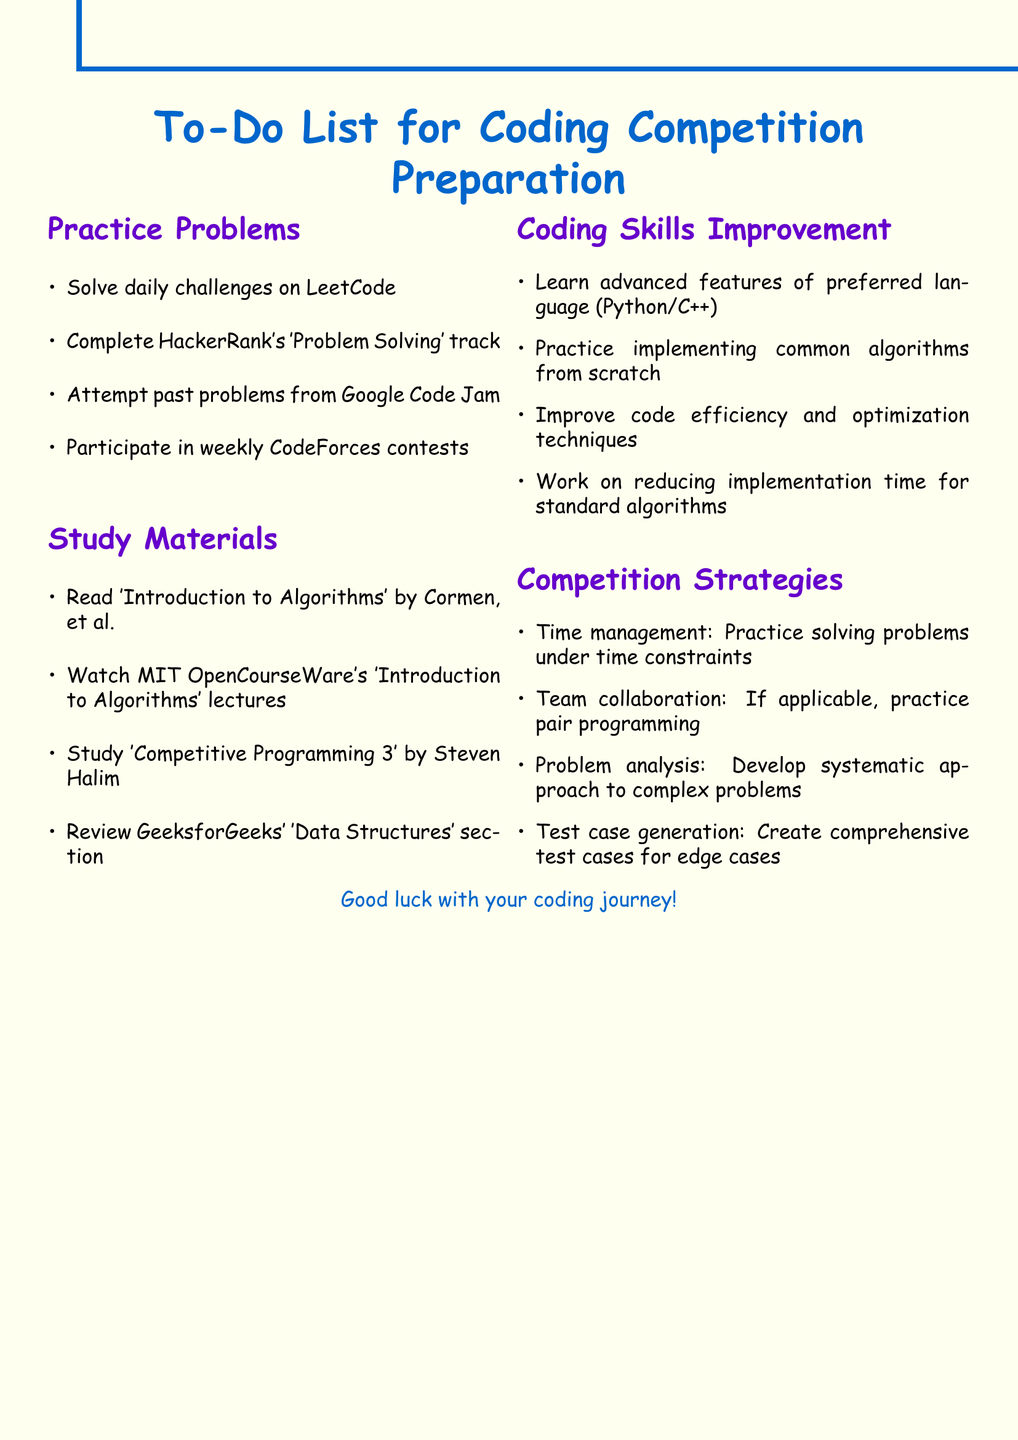What is one platform mentioned for daily challenges? The document lists LeetCode as a platform for daily challenges in the Practice Problems section.
Answer: LeetCode Which book is recommended for algorithms study? 'Introduction to Algorithms' by Cormen, Leiserson, Rivest, and Stein is mentioned as a recommended study material in the Study Materials section.
Answer: Introduction to Algorithms How many sections are there in total? The document contains four sections: Practice Problems, Study Materials, Coding Skills Improvement, and Competition Strategies.
Answer: Four What is one strategy for time management mentioned? The document suggests practicing solving problems under time constraints as a strategy in the Competition Strategies section.
Answer: Solving problems under time constraints Who is the author of 'Competitive Programming 3'? The document states that 'Competitive Programming 3' is by Steven Halim, mentioned in the Study Materials section.
Answer: Steven Halim What should you study for coding skills improvement? The document suggests learning advanced features of your preferred programming language as part of coding skills improvement in the Coding Skills Improvement section.
Answer: Advanced features of your preferred programming language Which competition's past problems should be attempted? The document mentions attempting past problems from Google Code Jam as part of the Practice Problems section.
Answer: Google Code Jam What is a systematic approach mentioned in the Competition Strategies section? The document highlights developing a systematic approach to breaking down complex problems under Competition Strategies.
Answer: Systematic approach to complex problems 